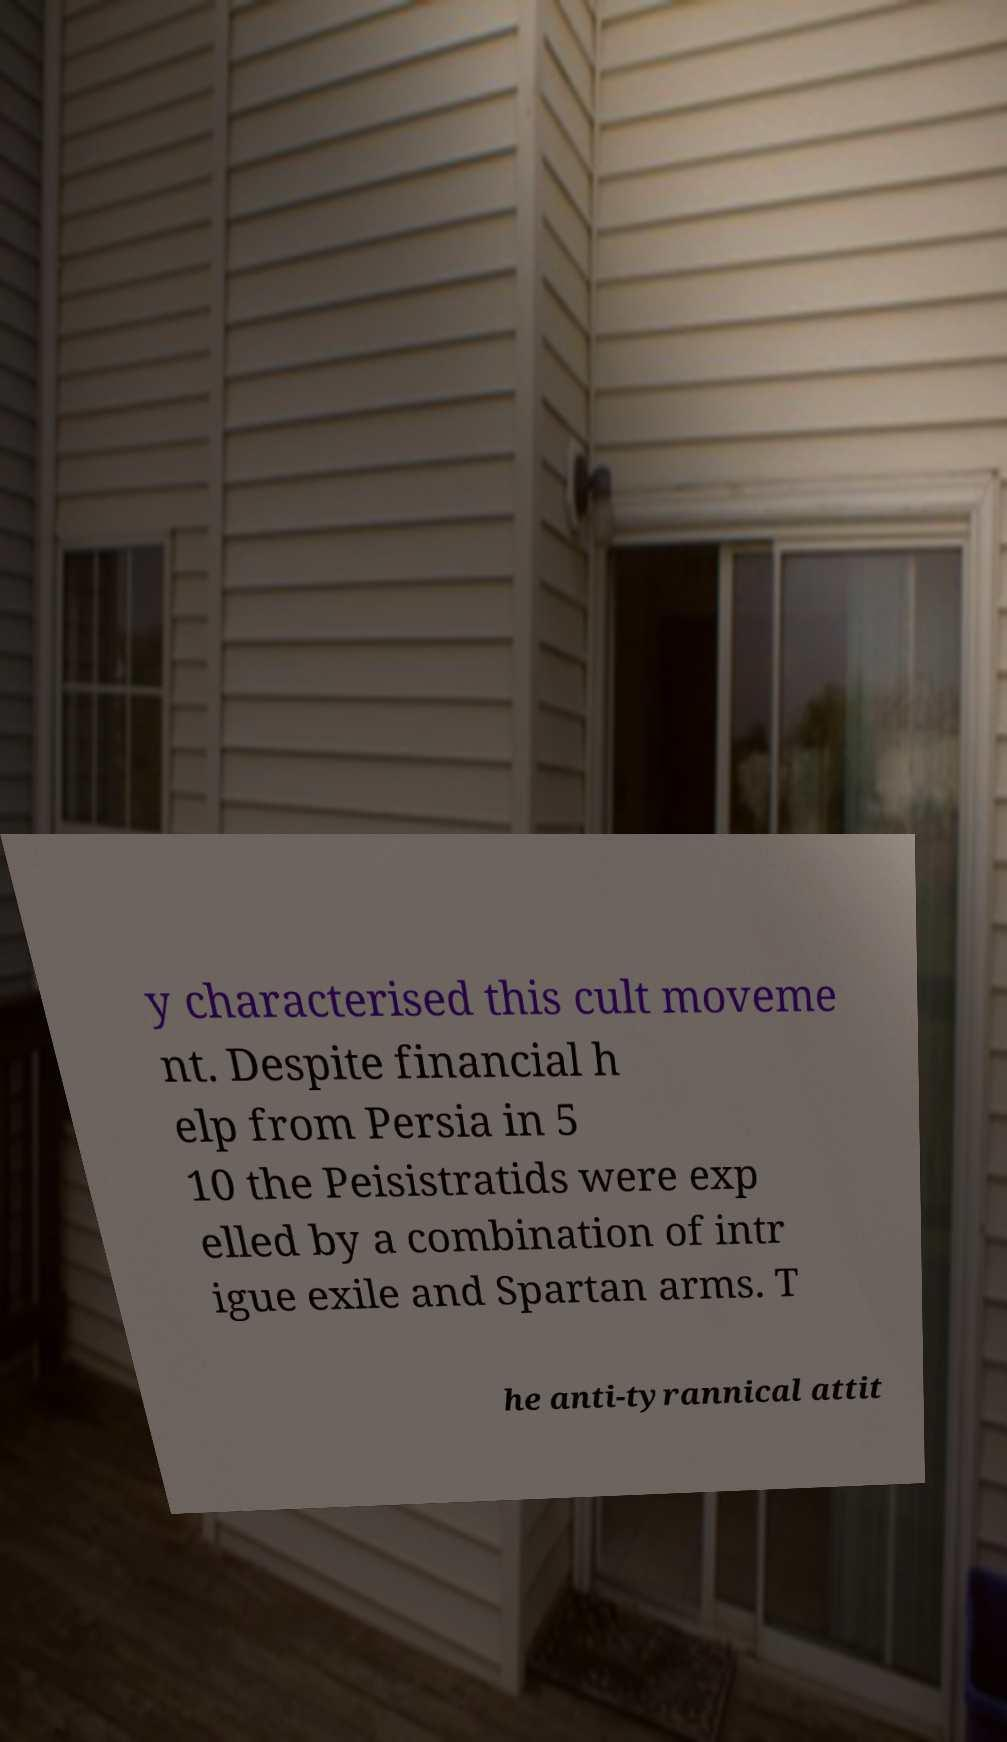For documentation purposes, I need the text within this image transcribed. Could you provide that? y characterised this cult moveme nt. Despite financial h elp from Persia in 5 10 the Peisistratids were exp elled by a combination of intr igue exile and Spartan arms. T he anti-tyrannical attit 